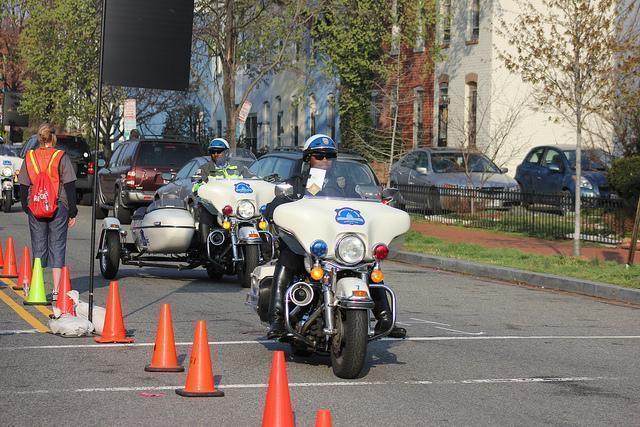What is the use of the following traffic cones?
Choose the right answer and clarify with the format: 'Answer: answer
Rationale: rationale.'
Options: Block road, stop vehicle, decoration, traffic redirection. Answer: traffic redirection.
Rationale: There are still vehicles moving, so they are not stopped or blocked, but it forces them to move down a different route. 